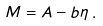Convert formula to latex. <formula><loc_0><loc_0><loc_500><loc_500>M = A - b \eta \, .</formula> 